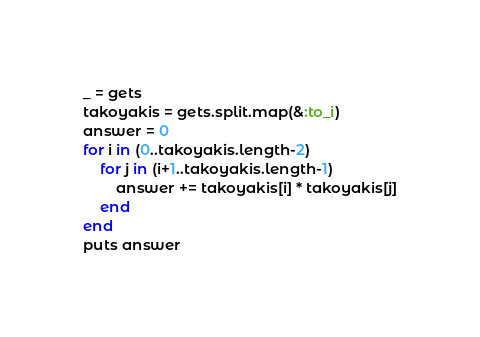<code> <loc_0><loc_0><loc_500><loc_500><_Ruby_>_ = gets
takoyakis = gets.split.map(&:to_i)
answer = 0
for i in (0..takoyakis.length-2)
    for j in (i+1..takoyakis.length-1)
        answer += takoyakis[i] * takoyakis[j]
    end
end
puts answer
</code> 